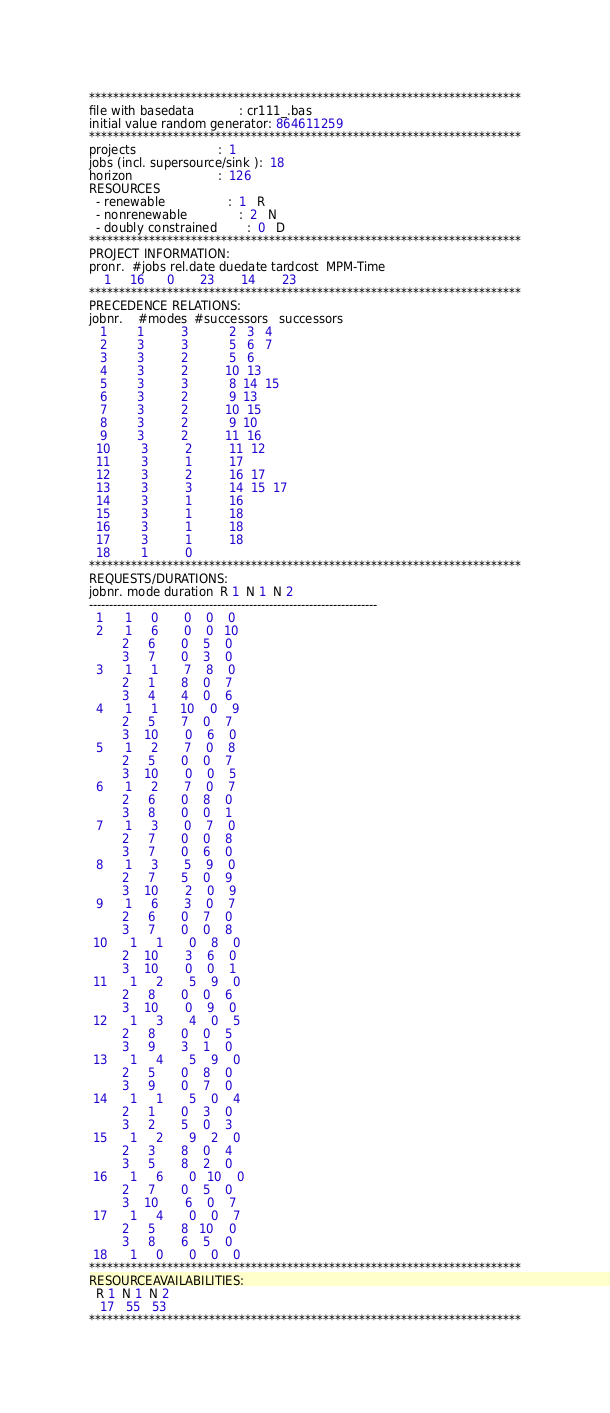Convert code to text. <code><loc_0><loc_0><loc_500><loc_500><_ObjectiveC_>************************************************************************
file with basedata            : cr111_.bas
initial value random generator: 864611259
************************************************************************
projects                      :  1
jobs (incl. supersource/sink ):  18
horizon                       :  126
RESOURCES
  - renewable                 :  1   R
  - nonrenewable              :  2   N
  - doubly constrained        :  0   D
************************************************************************
PROJECT INFORMATION:
pronr.  #jobs rel.date duedate tardcost  MPM-Time
    1     16      0       23       14       23
************************************************************************
PRECEDENCE RELATIONS:
jobnr.    #modes  #successors   successors
   1        1          3           2   3   4
   2        3          3           5   6   7
   3        3          2           5   6
   4        3          2          10  13
   5        3          3           8  14  15
   6        3          2           9  13
   7        3          2          10  15
   8        3          2           9  10
   9        3          2          11  16
  10        3          2          11  12
  11        3          1          17
  12        3          2          16  17
  13        3          3          14  15  17
  14        3          1          16
  15        3          1          18
  16        3          1          18
  17        3          1          18
  18        1          0        
************************************************************************
REQUESTS/DURATIONS:
jobnr. mode duration  R 1  N 1  N 2
------------------------------------------------------------------------
  1      1     0       0    0    0
  2      1     6       0    0   10
         2     6       0    5    0
         3     7       0    3    0
  3      1     1       7    8    0
         2     1       8    0    7
         3     4       4    0    6
  4      1     1      10    0    9
         2     5       7    0    7
         3    10       0    6    0
  5      1     2       7    0    8
         2     5       0    0    7
         3    10       0    0    5
  6      1     2       7    0    7
         2     6       0    8    0
         3     8       0    0    1
  7      1     3       0    7    0
         2     7       0    0    8
         3     7       0    6    0
  8      1     3       5    9    0
         2     7       5    0    9
         3    10       2    0    9
  9      1     6       3    0    7
         2     6       0    7    0
         3     7       0    0    8
 10      1     1       0    8    0
         2    10       3    6    0
         3    10       0    0    1
 11      1     2       5    9    0
         2     8       0    0    6
         3    10       0    9    0
 12      1     3       4    0    5
         2     8       0    0    5
         3     9       3    1    0
 13      1     4       5    9    0
         2     5       0    8    0
         3     9       0    7    0
 14      1     1       5    0    4
         2     1       0    3    0
         3     2       5    0    3
 15      1     2       9    2    0
         2     3       8    0    4
         3     5       8    2    0
 16      1     6       0   10    0
         2     7       0    5    0
         3    10       6    0    7
 17      1     4       0    0    7
         2     5       8   10    0
         3     8       6    5    0
 18      1     0       0    0    0
************************************************************************
RESOURCEAVAILABILITIES:
  R 1  N 1  N 2
   17   55   53
************************************************************************
</code> 